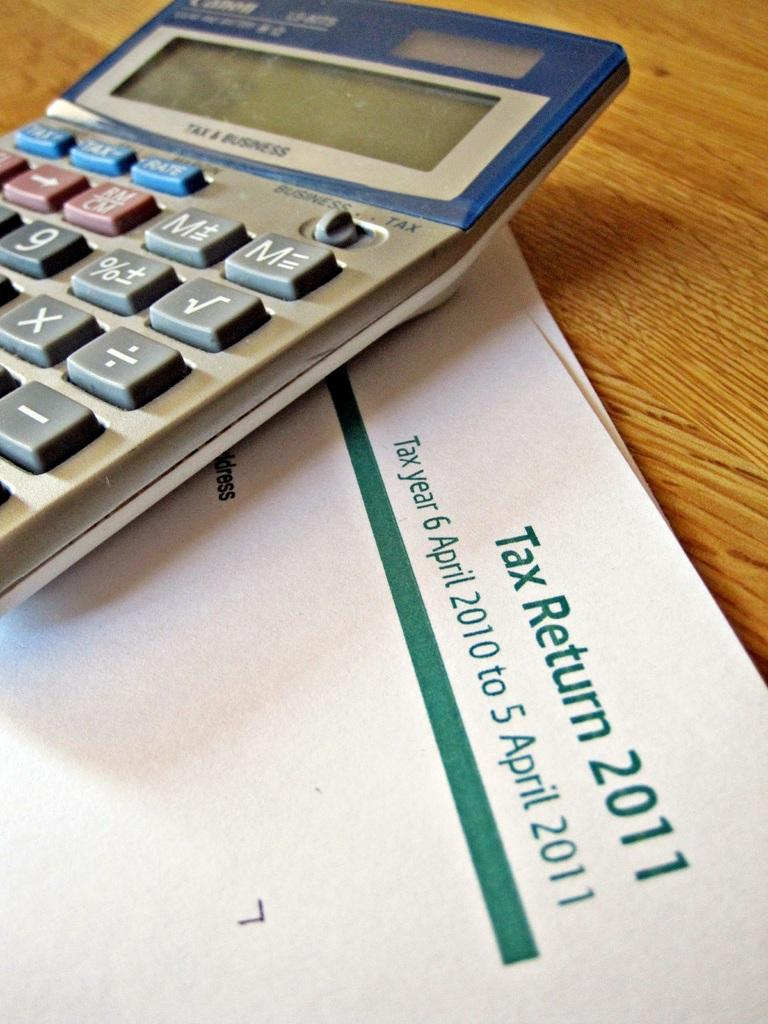<image>
Give a short and clear explanation of the subsequent image. the words tax return are on the white paper 